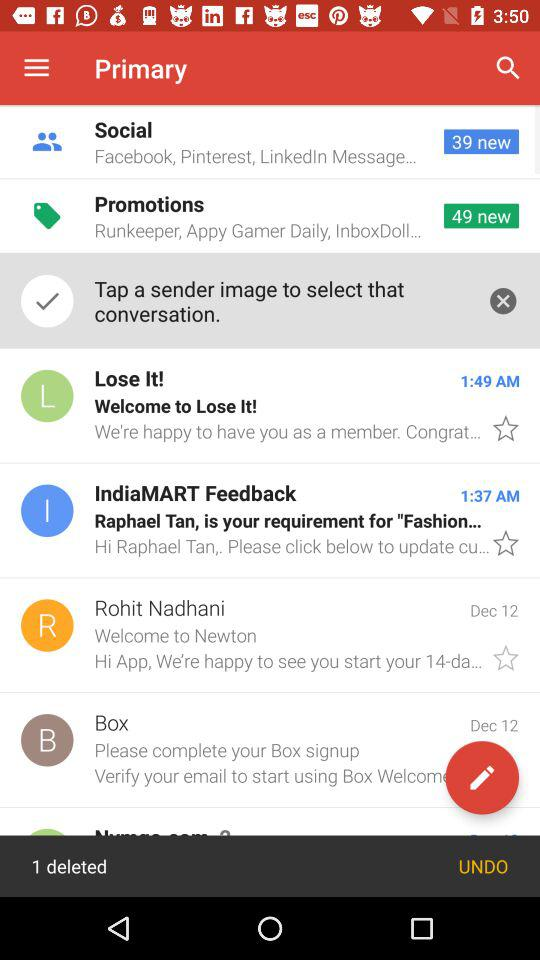How many messages have been deleted?
Answer the question using a single word or phrase. 1 